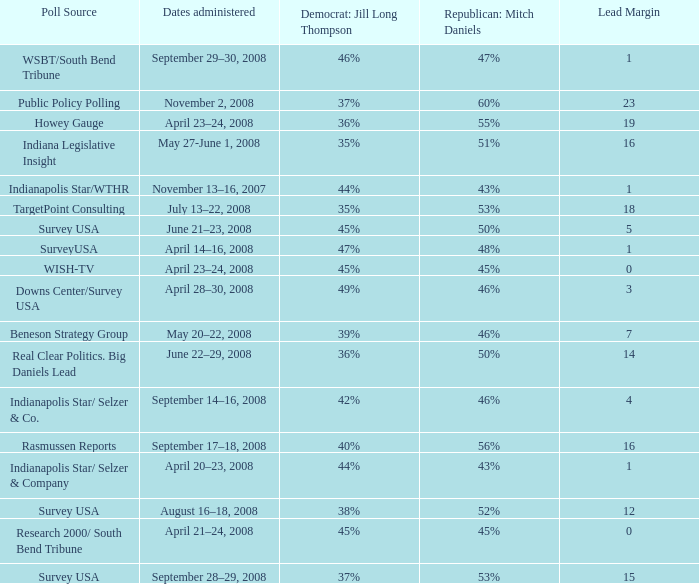What is the lowest Lead Margin when Republican: Mitch Daniels was polling at 48%? 1.0. 